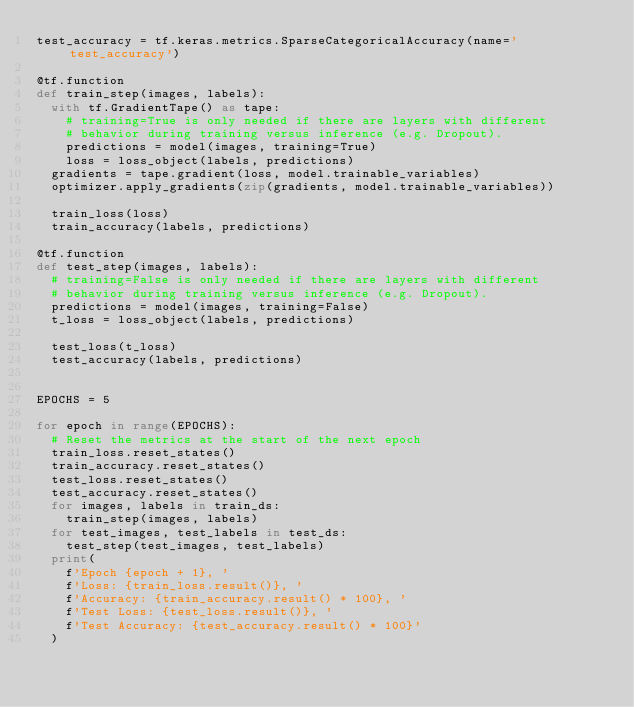Convert code to text. <code><loc_0><loc_0><loc_500><loc_500><_Python_>test_accuracy = tf.keras.metrics.SparseCategoricalAccuracy(name='test_accuracy')

@tf.function
def train_step(images, labels):
  with tf.GradientTape() as tape:
    # training=True is only needed if there are layers with different
    # behavior during training versus inference (e.g. Dropout).
    predictions = model(images, training=True)
    loss = loss_object(labels, predictions)
  gradients = tape.gradient(loss, model.trainable_variables)
  optimizer.apply_gradients(zip(gradients, model.trainable_variables))

  train_loss(loss)
  train_accuracy(labels, predictions)

@tf.function
def test_step(images, labels):
  # training=False is only needed if there are layers with different
  # behavior during training versus inference (e.g. Dropout).
  predictions = model(images, training=False)
  t_loss = loss_object(labels, predictions)

  test_loss(t_loss)
  test_accuracy(labels, predictions)


EPOCHS = 5

for epoch in range(EPOCHS):
  # Reset the metrics at the start of the next epoch
  train_loss.reset_states()
  train_accuracy.reset_states()
  test_loss.reset_states()
  test_accuracy.reset_states()
  for images, labels in train_ds:
    train_step(images, labels)
  for test_images, test_labels in test_ds:
    test_step(test_images, test_labels)
  print(
    f'Epoch {epoch + 1}, '
    f'Loss: {train_loss.result()}, '
    f'Accuracy: {train_accuracy.result() * 100}, '
    f'Test Loss: {test_loss.result()}, '
    f'Test Accuracy: {test_accuracy.result() * 100}'
  )
</code> 